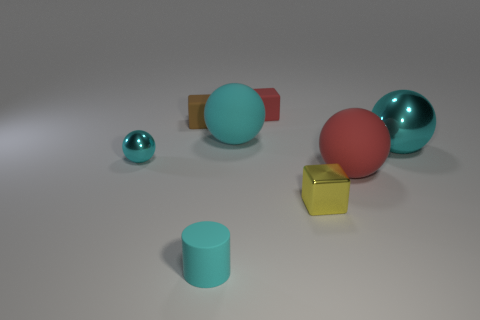What size is the cylinder that is the same color as the tiny sphere?
Make the answer very short. Small. Do the big red thing and the small red object have the same shape?
Provide a short and direct response. No. What material is the red object that is the same shape as the yellow thing?
Your response must be concise. Rubber. How many shiny objects have the same color as the tiny shiny sphere?
Offer a very short reply. 1. There is a brown thing that is made of the same material as the tiny red cube; what size is it?
Give a very brief answer. Small. What number of brown objects are shiny blocks or small blocks?
Offer a terse response. 1. What number of small brown rubber objects are behind the metallic object that is left of the tiny cyan cylinder?
Offer a terse response. 1. Is the number of rubber spheres in front of the cyan cylinder greater than the number of small objects in front of the red ball?
Keep it short and to the point. No. What is the small ball made of?
Offer a very short reply. Metal. Is there a metallic sphere that has the same size as the cyan matte sphere?
Your answer should be very brief. Yes. 